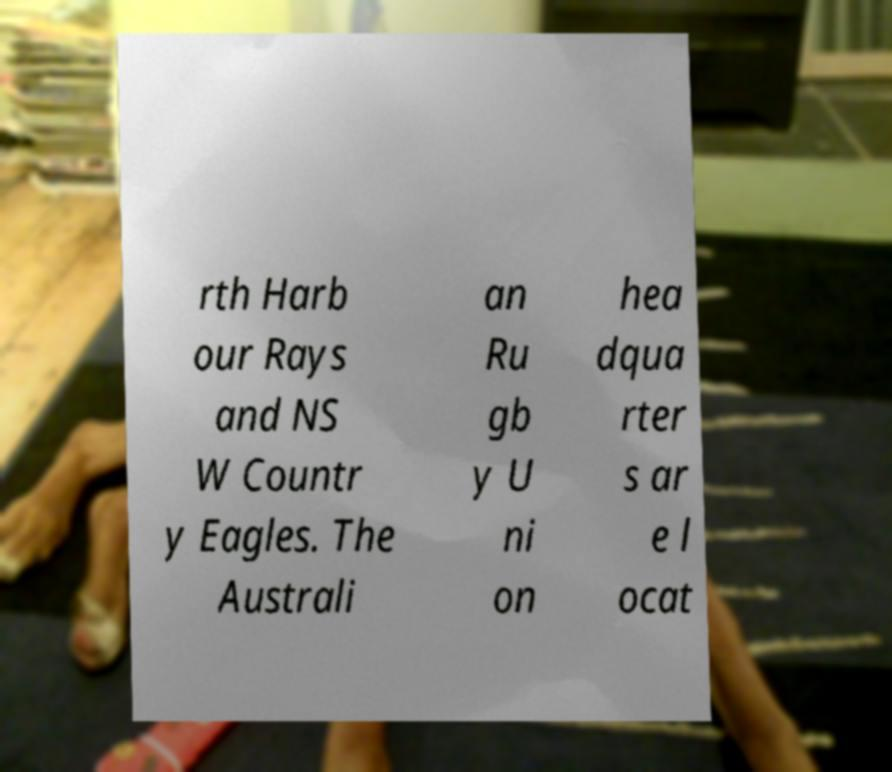Could you assist in decoding the text presented in this image and type it out clearly? rth Harb our Rays and NS W Countr y Eagles. The Australi an Ru gb y U ni on hea dqua rter s ar e l ocat 